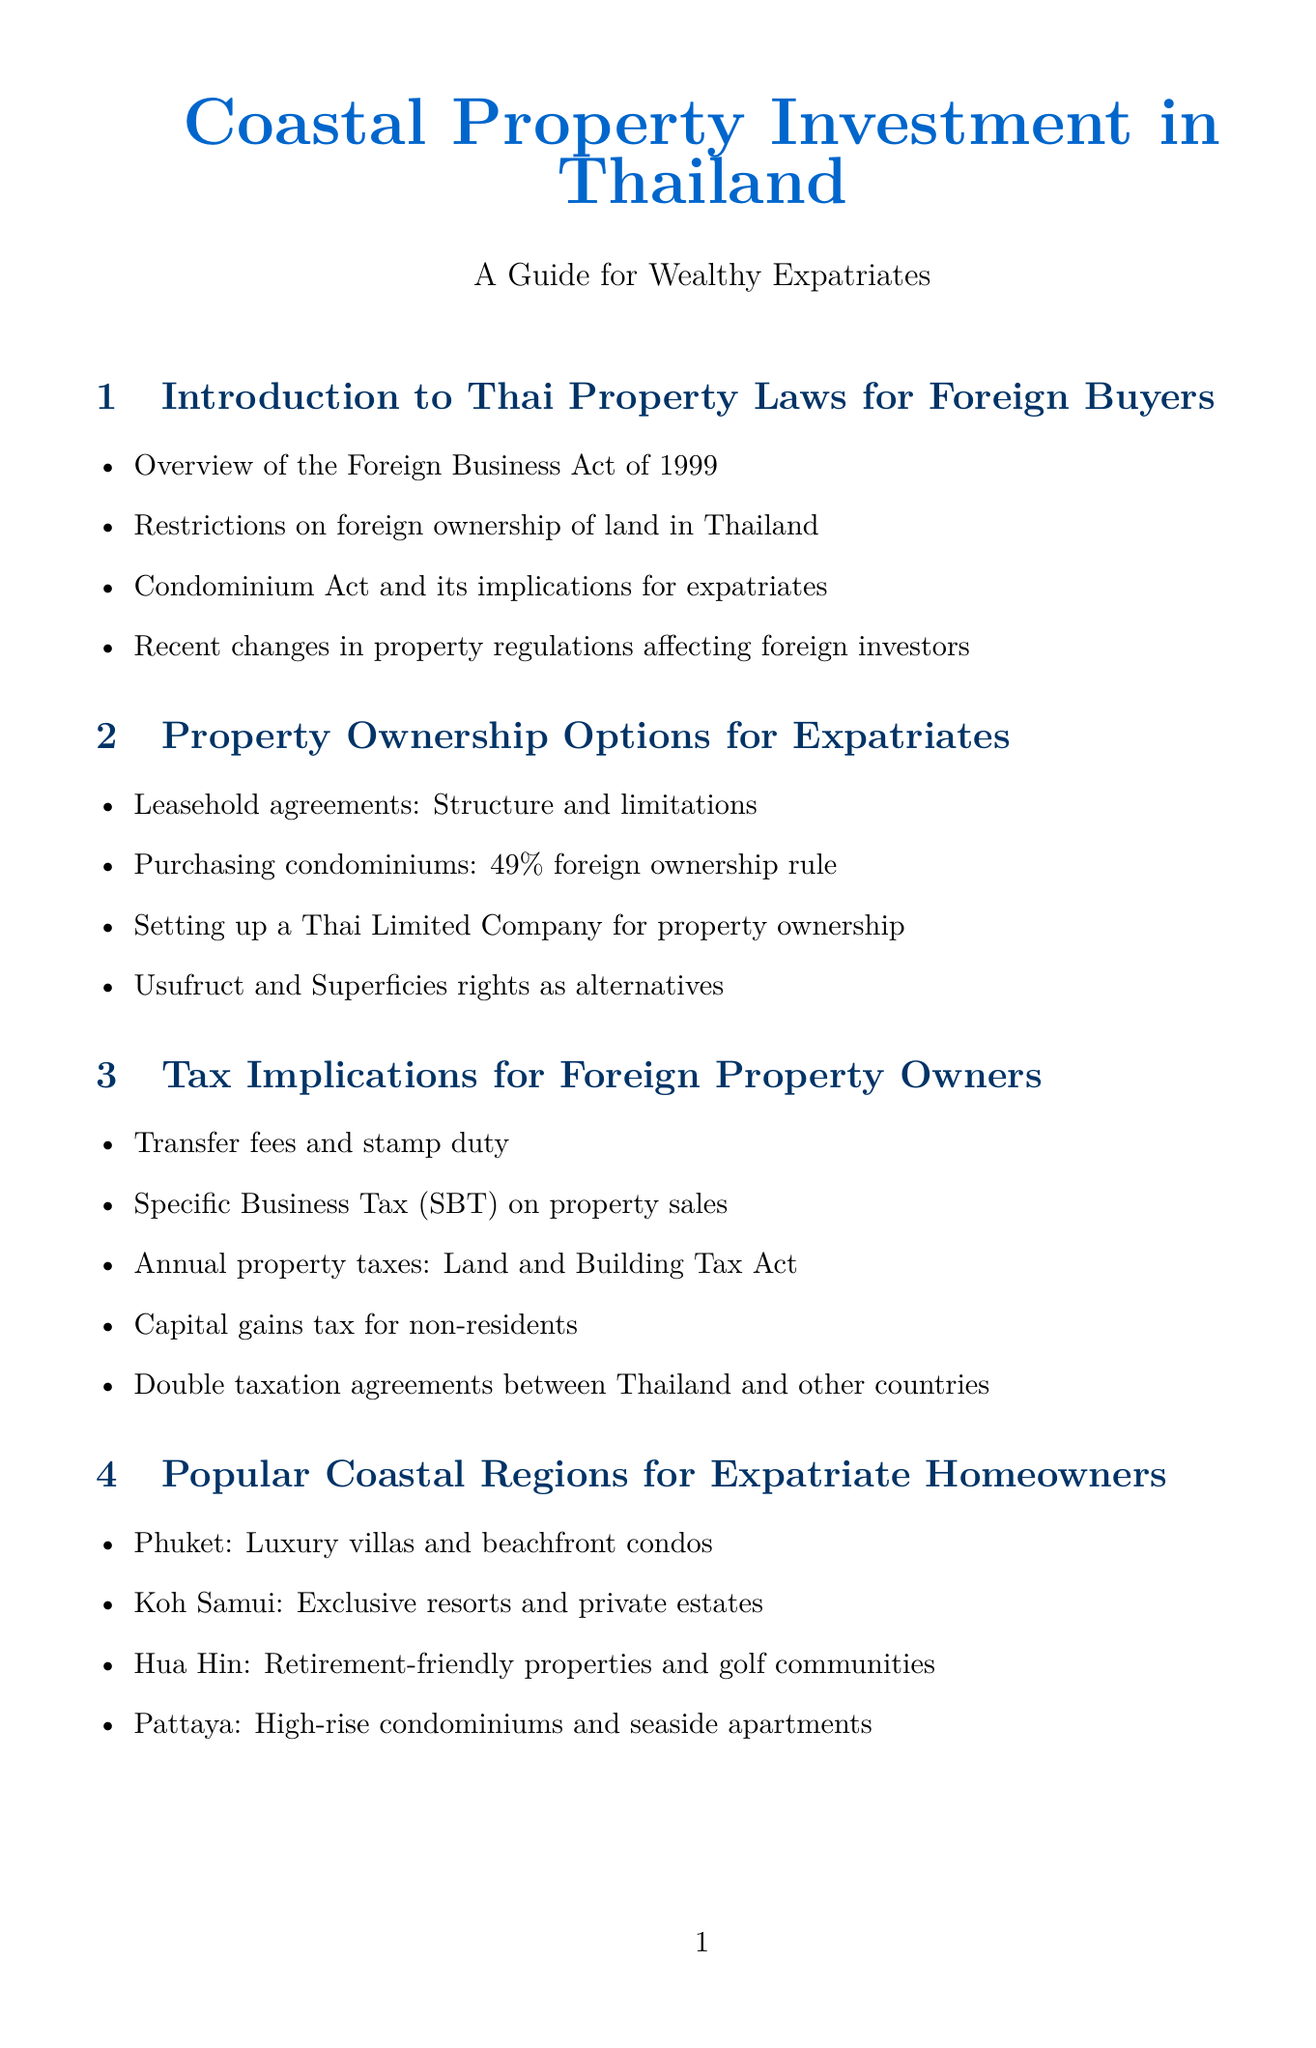What is the title of the report? The title is provided at the beginning of the document, stating "Coastal Property Investment in Thailand."
Answer: Coastal Property Investment in Thailand What is the ownership structure of John and Sarah Thompson? The document specifies that John and Sarah Thompson have a "30-year renewable lease" for their property.
Answer: 30-year renewable lease Which law outlines restrictions on foreign ownership of land in Thailand? The introduction mentions the "Foreign Business Act of 1999" as the relevant law regarding foreign ownership.
Answer: Foreign Business Act of 1999 Which coastal region is known for luxury villas and beachfront condos? The section on popular coastal regions identifies "Phuket" for luxury villas and condos.
Answer: Phuket What type of financing options are available for foreign buyers? The document lists various financing options, including "Thai banks offering mortgages to non-residents" and "International banks with presence in Thailand."
Answer: Thai banks offering mortgages to non-residents What percentage of foreign ownership is allowed when purchasing condominiums? The report states that there is a "49% foreign ownership rule" applicable to condominiums.
Answer: 49% Who is the owner of the beachfront condo in Koh Samui? The case studies section identifies "Hans Mueller" as the owner of the beachfront condo in Koh Samui.
Answer: Hans Mueller What are the key learnings from Robert Chen's case? The document mentions Robert Chen's learning as "Advantages of diversifying investment portfolio with Thai real estate."
Answer: Advantages of diversifying investment portfolio with Thai real estate What is the name of the act governing annual property taxes in Thailand? The document refers to the "Land and Building Tax Act" concerning annual property taxes.
Answer: Land and Building Tax Act 